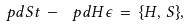<formula> <loc_0><loc_0><loc_500><loc_500>\ p d { S } { t } \, - \, \ p d { H } { \epsilon } \, = \, \{ H , \, S \} ,</formula> 